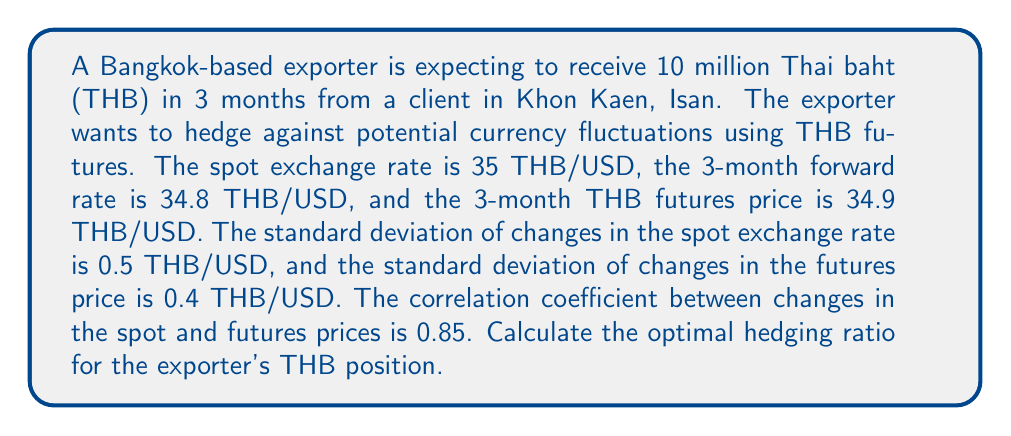What is the answer to this math problem? To calculate the optimal hedging ratio, we'll use the following formula:

$$ h^* = \rho \frac{\sigma_S}{\sigma_F} $$

Where:
$h^*$ = optimal hedging ratio
$\rho$ = correlation coefficient between changes in spot and futures prices
$\sigma_S$ = standard deviation of changes in the spot exchange rate
$\sigma_F$ = standard deviation of changes in the futures price

Given:
$\rho = 0.85$
$\sigma_S = 0.5$ THB/USD
$\sigma_F = 0.4$ THB/USD

Step 1: Substitute the values into the formula.

$$ h^* = 0.85 \frac{0.5}{0.4} $$

Step 2: Perform the calculation.

$$ h^* = 0.85 \times 1.25 = 1.0625 $$

The optimal hedging ratio is 1.0625, which means the exporter should hedge 106.25% of their THB position using THB futures.

Step 3: Calculate the number of futures contracts needed.

Amount to hedge = 10 million THB
Futures price = 34.9 THB/USD
Contract size = Typically 5 million THB (assumed for this problem)

Number of contracts = $\frac{10,000,000 \times 1.0625}{5,000,000} = 2.125$

Since we can't trade fractional contracts, the exporter should round to the nearest whole number and use 2 futures contracts to hedge their position.
Answer: The optimal hedging ratio is 1.0625, or 106.25%. The exporter should use 2 THB futures contracts to hedge their 10 million THB position. 